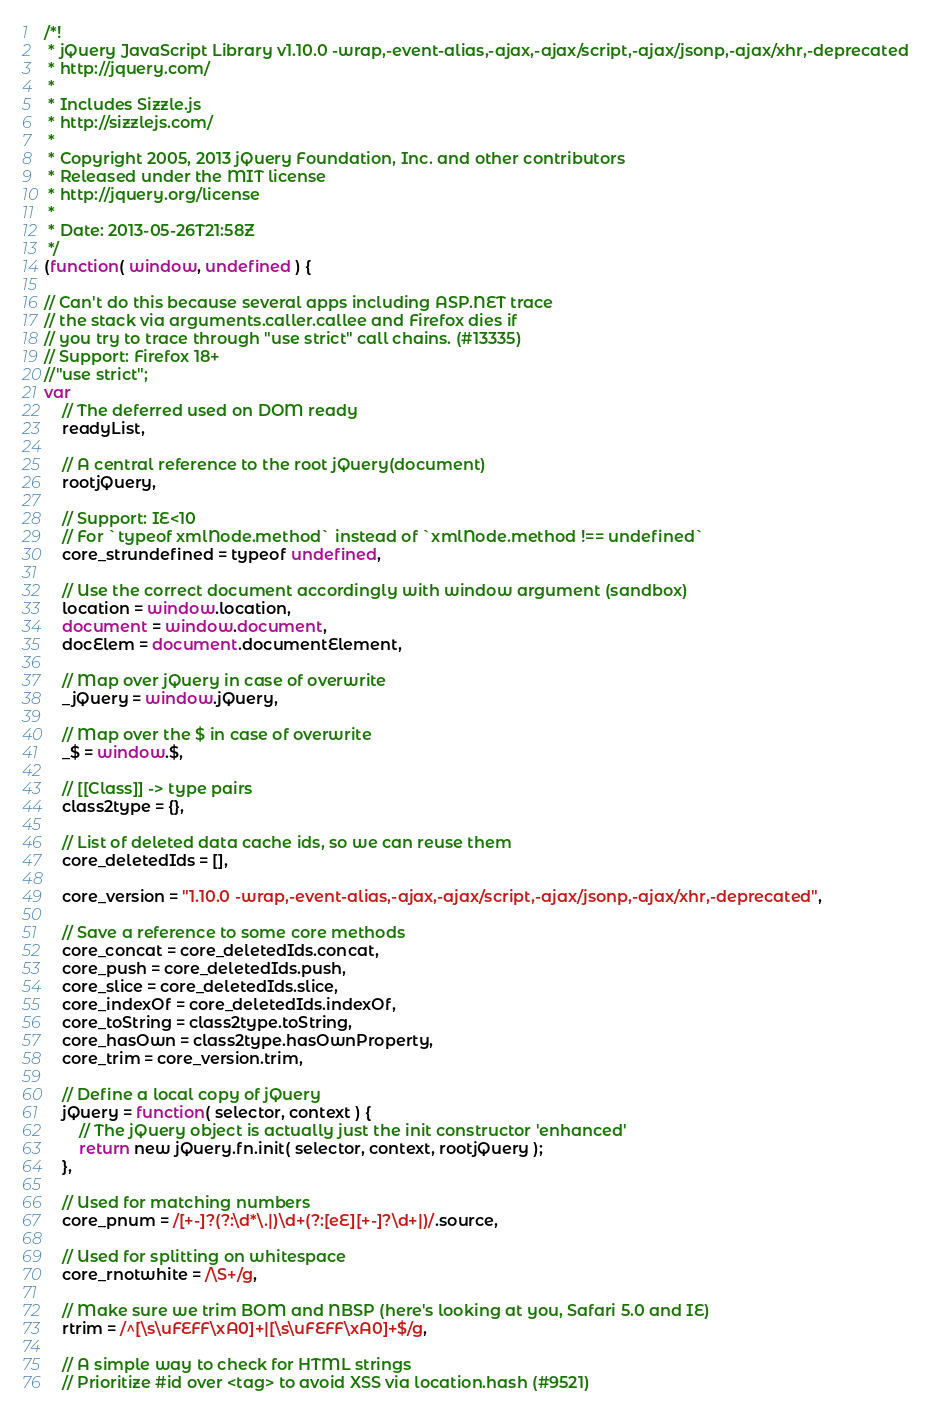<code> <loc_0><loc_0><loc_500><loc_500><_JavaScript_>/*!
 * jQuery JavaScript Library v1.10.0 -wrap,-event-alias,-ajax,-ajax/script,-ajax/jsonp,-ajax/xhr,-deprecated
 * http://jquery.com/
 *
 * Includes Sizzle.js
 * http://sizzlejs.com/
 *
 * Copyright 2005, 2013 jQuery Foundation, Inc. and other contributors
 * Released under the MIT license
 * http://jquery.org/license
 *
 * Date: 2013-05-26T21:58Z
 */
(function( window, undefined ) {

// Can't do this because several apps including ASP.NET trace
// the stack via arguments.caller.callee and Firefox dies if
// you try to trace through "use strict" call chains. (#13335)
// Support: Firefox 18+
//"use strict";
var
	// The deferred used on DOM ready
	readyList,

	// A central reference to the root jQuery(document)
	rootjQuery,

	// Support: IE<10
	// For `typeof xmlNode.method` instead of `xmlNode.method !== undefined`
	core_strundefined = typeof undefined,

	// Use the correct document accordingly with window argument (sandbox)
	location = window.location,
	document = window.document,
	docElem = document.documentElement,

	// Map over jQuery in case of overwrite
	_jQuery = window.jQuery,

	// Map over the $ in case of overwrite
	_$ = window.$,

	// [[Class]] -> type pairs
	class2type = {},

	// List of deleted data cache ids, so we can reuse them
	core_deletedIds = [],

	core_version = "1.10.0 -wrap,-event-alias,-ajax,-ajax/script,-ajax/jsonp,-ajax/xhr,-deprecated",

	// Save a reference to some core methods
	core_concat = core_deletedIds.concat,
	core_push = core_deletedIds.push,
	core_slice = core_deletedIds.slice,
	core_indexOf = core_deletedIds.indexOf,
	core_toString = class2type.toString,
	core_hasOwn = class2type.hasOwnProperty,
	core_trim = core_version.trim,

	// Define a local copy of jQuery
	jQuery = function( selector, context ) {
		// The jQuery object is actually just the init constructor 'enhanced'
		return new jQuery.fn.init( selector, context, rootjQuery );
	},

	// Used for matching numbers
	core_pnum = /[+-]?(?:\d*\.|)\d+(?:[eE][+-]?\d+|)/.source,

	// Used for splitting on whitespace
	core_rnotwhite = /\S+/g,

	// Make sure we trim BOM and NBSP (here's looking at you, Safari 5.0 and IE)
	rtrim = /^[\s\uFEFF\xA0]+|[\s\uFEFF\xA0]+$/g,

	// A simple way to check for HTML strings
	// Prioritize #id over <tag> to avoid XSS via location.hash (#9521)</code> 